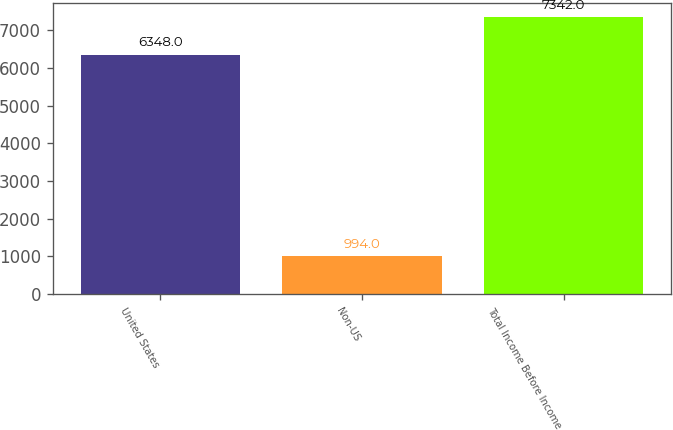Convert chart to OTSL. <chart><loc_0><loc_0><loc_500><loc_500><bar_chart><fcel>United States<fcel>Non-US<fcel>Total Income Before Income<nl><fcel>6348<fcel>994<fcel>7342<nl></chart> 